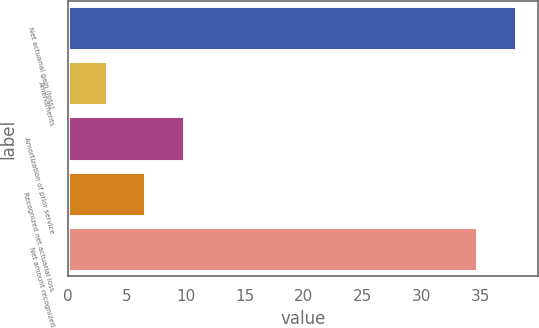Convert chart to OTSL. <chart><loc_0><loc_0><loc_500><loc_500><bar_chart><fcel>Net actuarial gain (loss)<fcel>Amendments<fcel>Amortization of prior service<fcel>Recognized net actuarial loss<fcel>Net amount recognized<nl><fcel>37.95<fcel>3.3<fcel>9.8<fcel>6.55<fcel>34.7<nl></chart> 